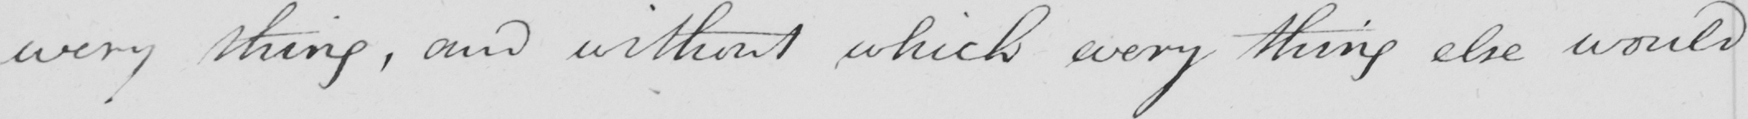Transcribe the text shown in this historical manuscript line. every thing , and without which every thing else would 